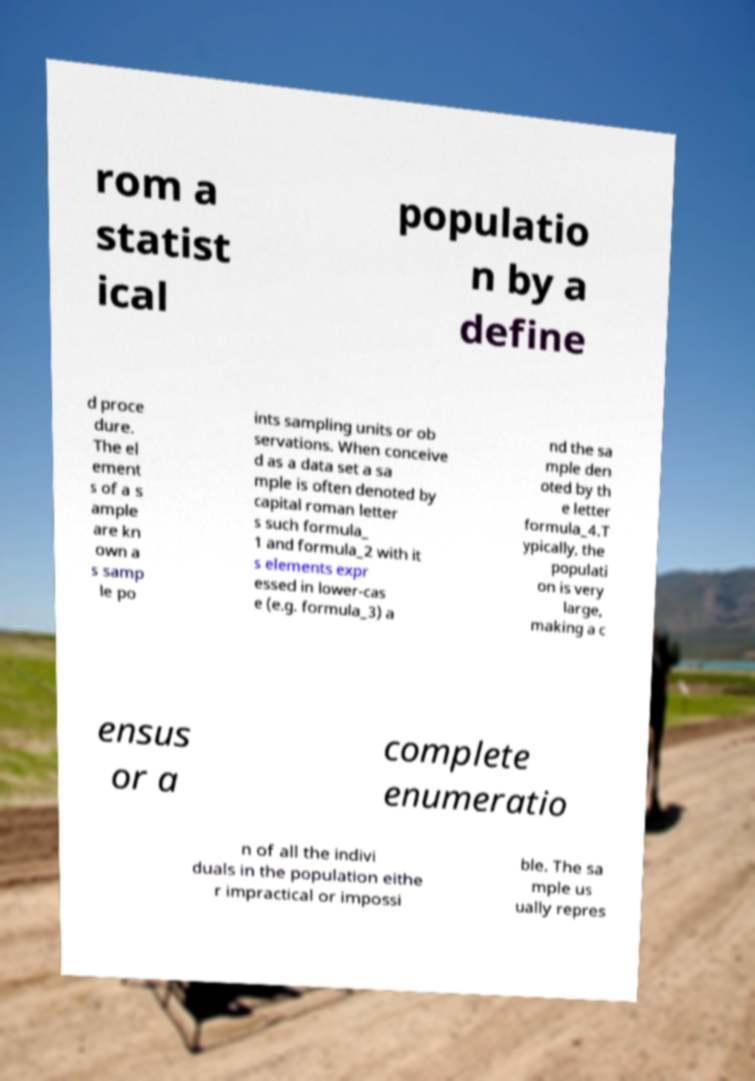Could you assist in decoding the text presented in this image and type it out clearly? rom a statist ical populatio n by a define d proce dure. The el ement s of a s ample are kn own a s samp le po ints sampling units or ob servations. When conceive d as a data set a sa mple is often denoted by capital roman letter s such formula_ 1 and formula_2 with it s elements expr essed in lower-cas e (e.g. formula_3) a nd the sa mple den oted by th e letter formula_4.T ypically, the populati on is very large, making a c ensus or a complete enumeratio n of all the indivi duals in the population eithe r impractical or impossi ble. The sa mple us ually repres 